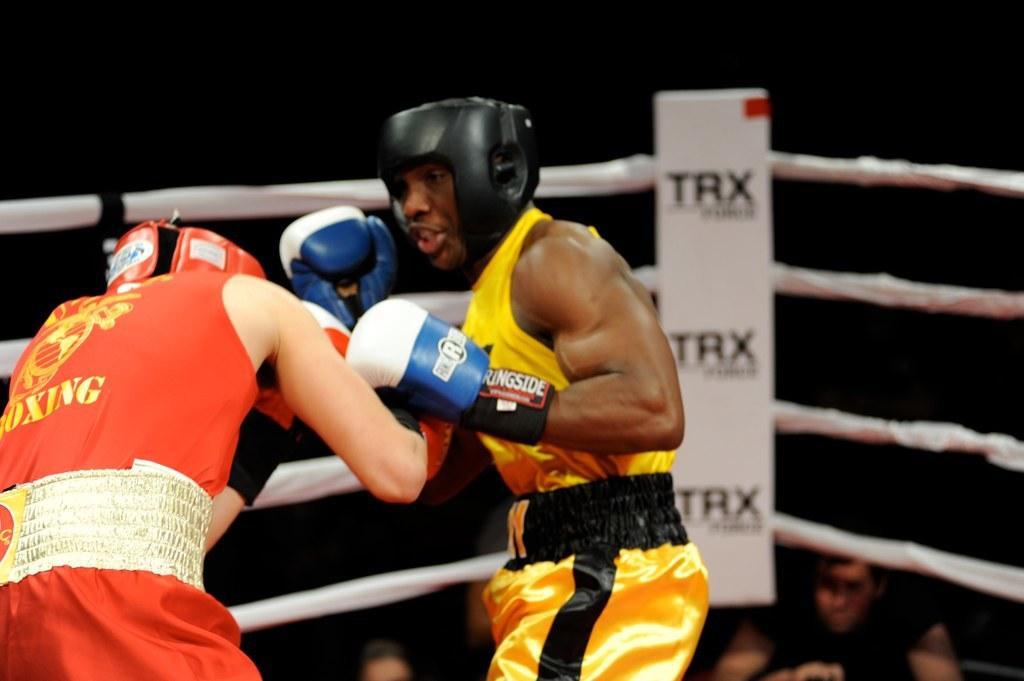Could you give a brief overview of what you see in this image? In this image I can see a person wearing orange colored jersey and another person wearing yellow and black color jersey are standing. I can see two of them are wearing gloves and helmets. In the background I can see the white collar boxing ring, few persons and the dark background. 